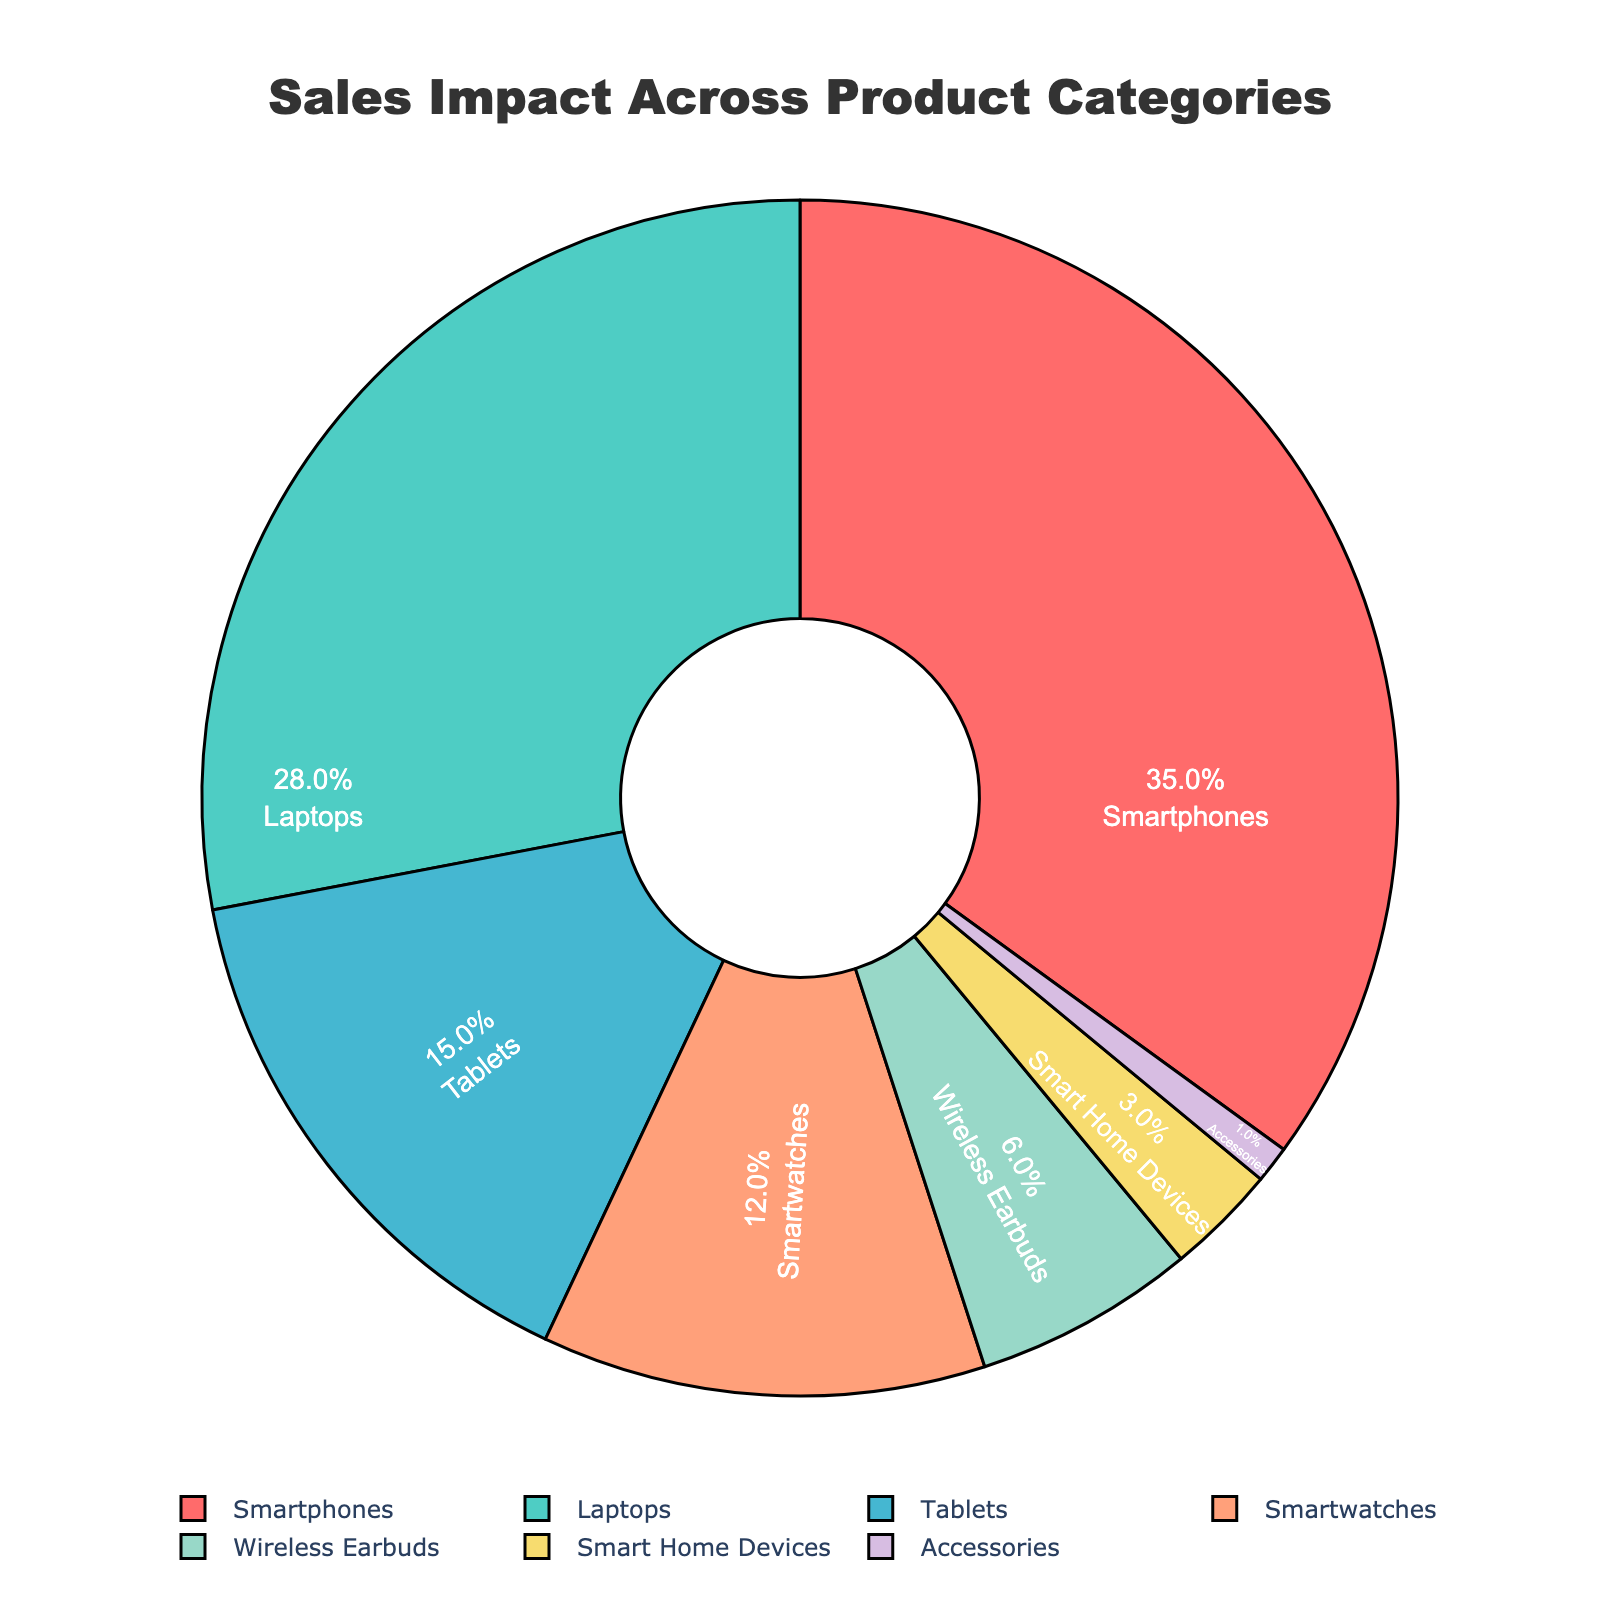What's the product category with the highest sales impact? The figure shows a pie chart with different sections labeled by product category. The largest section is labeled "Smartphones," indicating that it has the highest sales impact.
Answer: Smartphones What's the combined percentage impact of Smart Home Devices and Accessories? The pie chart displays the percentage impact for each product category. The percentages for Smart Home Devices and Accessories are 3% and 1%, respectively, so their combined impact is 3% + 1% = 4%.
Answer: 4% Which product categories have a greater sales impact than Wireless Earbuds? According to the pie chart, Wireless Earbuds have a 6% impact. Categories with a greater impact are Smartphones (35%), Laptops (28%), Tablets (15%), and Smartwatches (12%).
Answer: Smartphones, Laptops, Tablets, Smartwatches How much more impactful are Smartphones compared to Tablets? The pie chart shows Smartphones have a 35% impact while Tablets have a 15% impact. The difference is 35% - 15% = 20%.
Answer: 20% What is the second most impactful product category? The pie chart reveals the impact percentages, with Laptops having the second largest section at 28%.
Answer: Laptops How much less impactful are Smartwatches compared to Laptops? The chart shows Smartwatches with a 12% impact and Laptops with a 28% impact. The difference is 28% - 12% = 16%.
Answer: 16% What is the average impact of the categories that have an impact of 10% or more? Categories with 10% or more impact are Smartphones (35%), Laptops (28%), Tablets (15%), and Smartwatches (12%). The total is 35% + 28% + 15% + 12% = 90%. There are 4 such categories, so the average is 90% / 4 = 22.5%.
Answer: 22.5% Does any category contribute more than half of the total sales impact? The largest section belongs to Smartphones with 35%, which is less than half of the total (50%). Thus, no category contributes more than half.
Answer: No What are the color representations of Wireless Earbuds and Accessories? Wireless Earbuds are shown in a light blue section of the pie chart, whereas Accessories are shown in a lavender section.
Answer: Light blue and lavender 